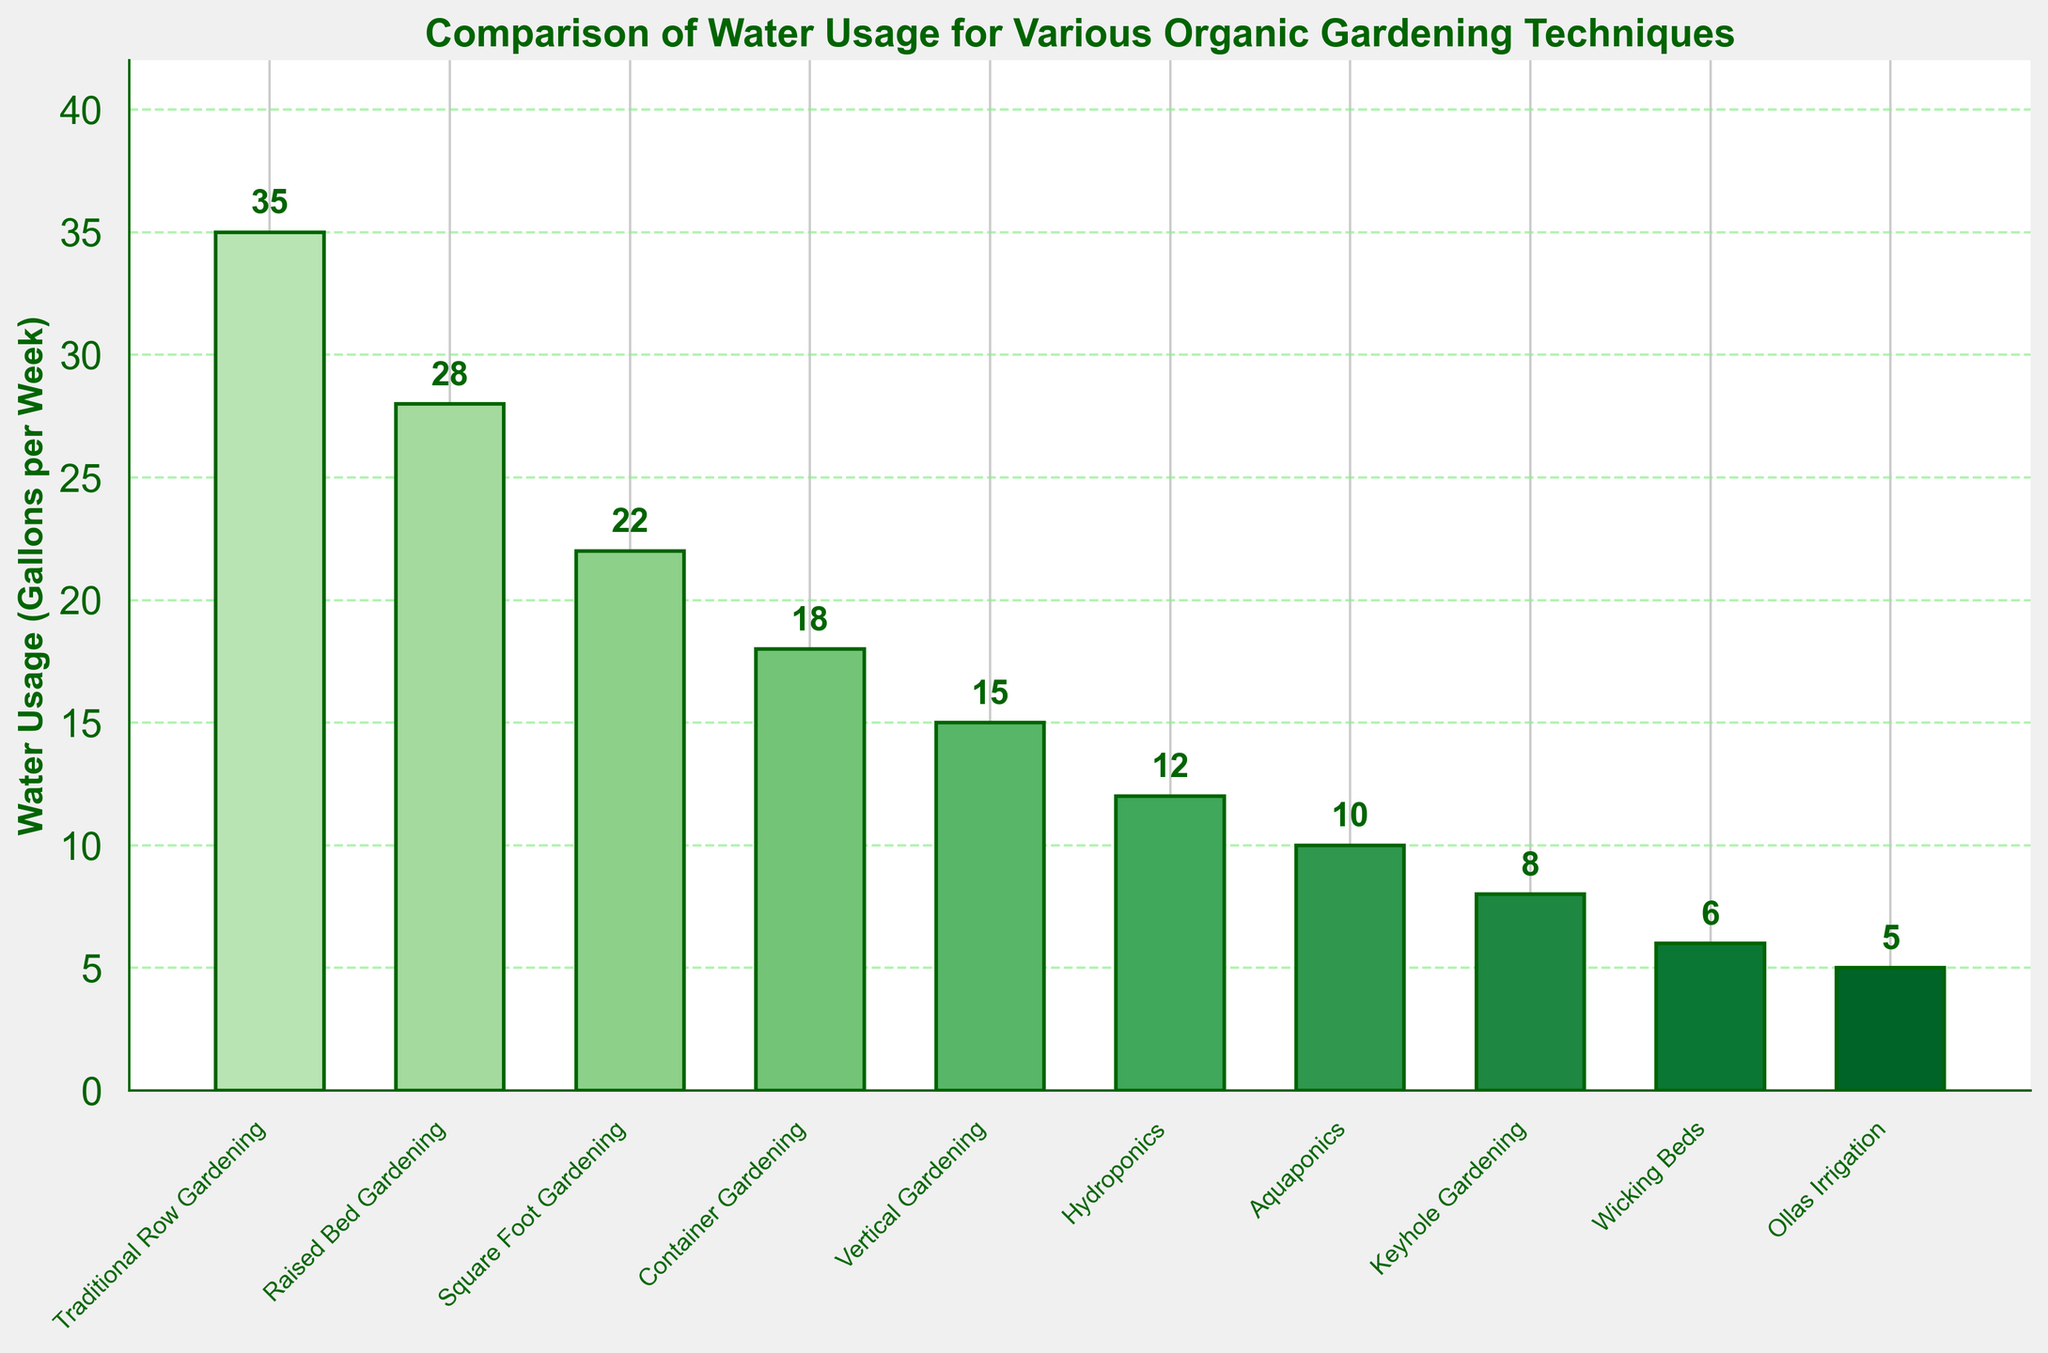What's the water usage difference between Traditional Row Gardening and Wicking Beds? To find the difference, subtract the water usage of Wicking Beds (6 gallons) from the water usage of Traditional Row Gardening (35 gallons): 35 - 6 = 29
Answer: 29 Which gardening technique uses the least water? By examining the water usage values for each technique, we see that the Ollas Irrigation technique has the lowest value, which is 5 gallons per week.
Answer: Ollas Irrigation What's the total weekly water usage for Container Gardening, Vertical Gardening, and Hydroponics combined? Add the water usage of Container Gardening (18 gallons), Vertical Gardening (15 gallons), and Hydroponics (12 gallons) together: 18 + 15 + 12 = 45
Answer: 45 Which technique uses more water: Square Foot Gardening or Keyhole Gardening? Compare the water usage values for Square Foot Gardening (22 gallons) and Keyhole Gardening (8 gallons). Since 22 is greater than 8, Square Foot Gardening uses more water.
Answer: Square Foot Gardening How much more water does Traditional Row Gardening use compared to Aquaponics? Subtract the water usage of Aquaponics (10 gallons) from the water usage of Traditional Row Gardening (35 gallons): 35 - 10 = 25
Answer: 25 Identify the two techniques with the closest water usage values and provide the difference in their usage. The two closest techniques are Hydroponics (12 gallons) and Aquaponics (10 gallons). The difference in their water usage is: 12 - 10 = 2
Answer: Hydroponics and Aquaponics; 2 List the techniques that use less than 20 gallons of water per week. By examining the water usage values, the techniques using less than 20 gallons per week are Container Gardening (18 gallons), Vertical Gardening (15 gallons), Hydroponics (12 gallons), Aquaponics (10 gallons), Keyhole Gardening (8 gallons), Wicking Beds (6 gallons), and Ollas Irrigation (5 gallons).
Answer: Container Gardening, Vertical Gardening, Hydroponics, Aquaponics, Keyhole Gardening, Wicking Beds, Ollas Irrigation Calculate the average weekly water usage of all the techniques. To find the average, sum all water usage values and divide by the number of techniques: (35+28+22+18+15+12+10+8+6+5) / 10 = 159 / 10 = 15.9
Answer: 15.9 Which technique uses two times more water than Wicking Beds? If Wicking Beds use 6 gallons, doubling this amount gives 12 gallons. Hydroponics uses 12 gallons of water per week, which is two times more than Wicking Beds.
Answer: Hydroponics What is the water usage range among the techniques? To find the range, subtract the smallest water usage value (Ollas Irrigation, 5 gallons) from the largest water usage value (Traditional Row Gardening, 35 gallons): 35 - 5 = 30
Answer: 30 